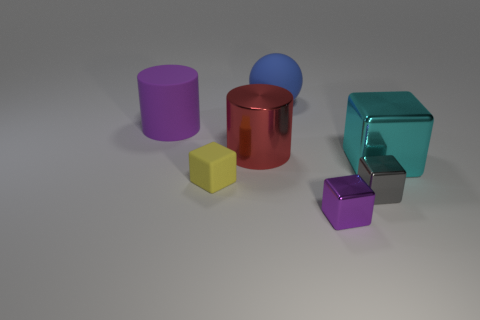Subtract all tiny gray metallic cubes. How many cubes are left? 3 Add 1 big cyan rubber blocks. How many objects exist? 8 Subtract all red cylinders. How many cylinders are left? 1 Add 2 gray shiny things. How many gray shiny things are left? 3 Add 6 small purple objects. How many small purple objects exist? 7 Subtract 1 gray cubes. How many objects are left? 6 Subtract all cylinders. How many objects are left? 5 Subtract 1 cylinders. How many cylinders are left? 1 Subtract all purple balls. Subtract all red cubes. How many balls are left? 1 Subtract all cyan cylinders. How many cyan blocks are left? 1 